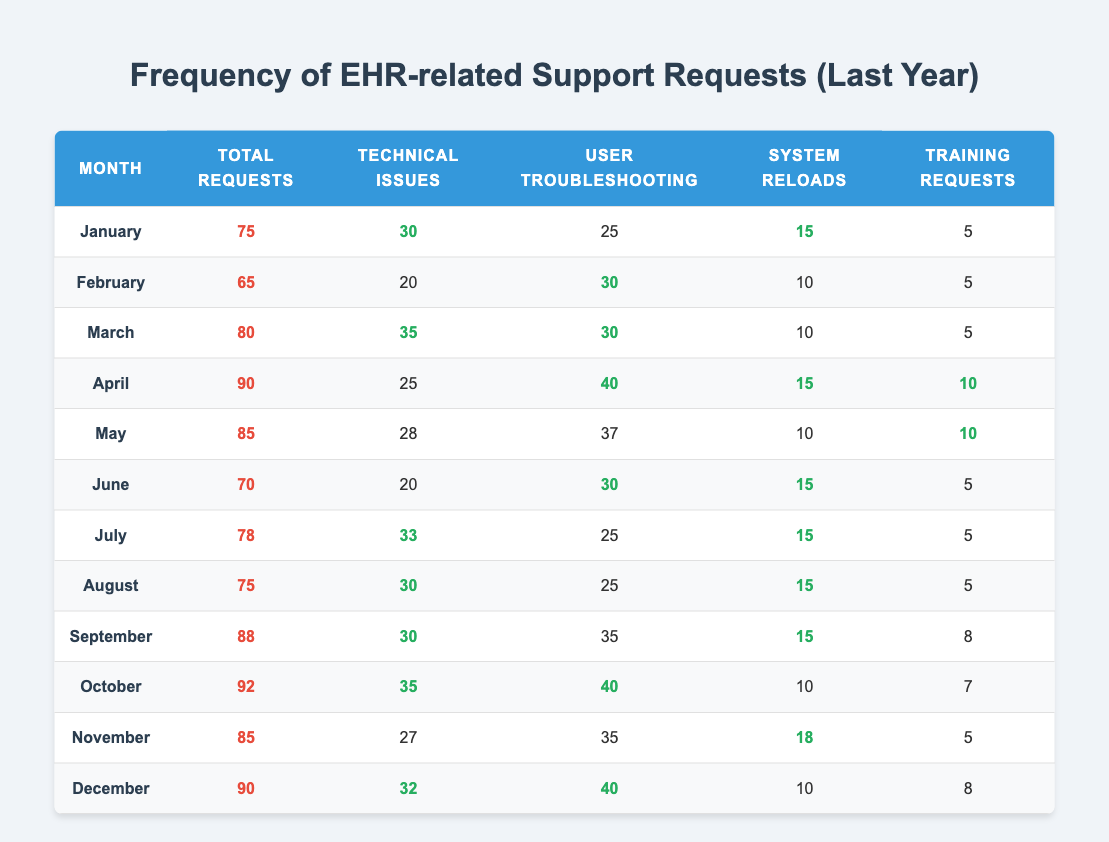What month had the highest total EHR support requests? By examining the "Total Requests" column, we find that October has the highest value at 92.
Answer: October How many technical issues were reported in April? In April, the "Technical Issues" column shows a total of 25.
Answer: 25 What is the average number of user troubleshooting requests for the year? Adding the user troubleshooting requests (25 + 30 + 30 + 40 + 37 + 30 + 25 + 25 + 35 + 40 + 35 + 40) gives  400, dividing by 12 months results in an average of 33.33.
Answer: 33.33 Which month had the most training requests? Looking at the "Training Requests" column, April achieves the highest count with 10 requests.
Answer: April Did the total number of requests decrease from January to February? Comparing "Total Requests," January has 75 and February has 65, confirming a decrease.
Answer: Yes How many more technical issues were reported in March than in June? The difference between March's 35 and June's 20 is calculated as 35 - 20, resulting in 15 more technical issues reported in March.
Answer: 15 In which month did user troubleshooting requests reach their peak, and what was the number? The peak for user troubleshooting was in October at 40 requests.
Answer: October, 40 What is the total number of system reloads across the entire year? Summing the system reloads (15 + 10 + 10 + 15 + 10 + 15 + 15 + 15 + 10 + 10 + 18 + 10) gives a total of 175.
Answer: 175 Which month had the least number of total requests, and what was that number? February had the least total requests with a count of 65.
Answer: February, 65 Was there an increase in total requests from October to November? October has 92 total requests while November has 85, indicating a decrease rather than an increase.
Answer: No 